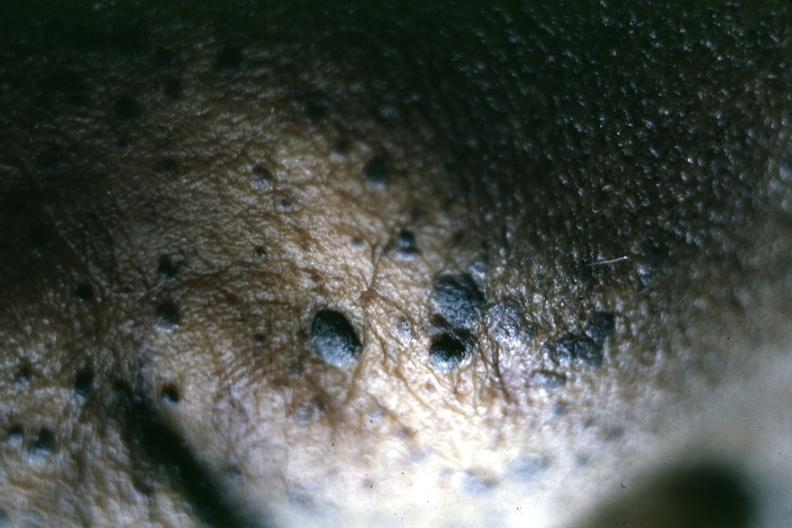does this image show close-up of typical lesions perspective of elevated pasted on lesions is well shown?
Answer the question using a single word or phrase. Yes 